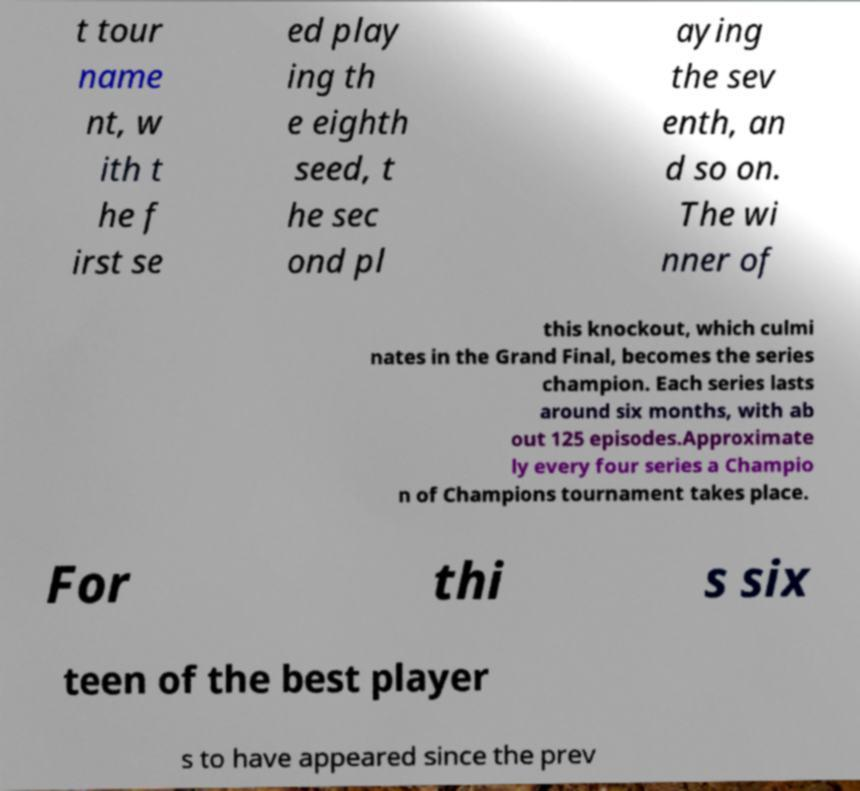Can you read and provide the text displayed in the image?This photo seems to have some interesting text. Can you extract and type it out for me? t tour name nt, w ith t he f irst se ed play ing th e eighth seed, t he sec ond pl aying the sev enth, an d so on. The wi nner of this knockout, which culmi nates in the Grand Final, becomes the series champion. Each series lasts around six months, with ab out 125 episodes.Approximate ly every four series a Champio n of Champions tournament takes place. For thi s six teen of the best player s to have appeared since the prev 